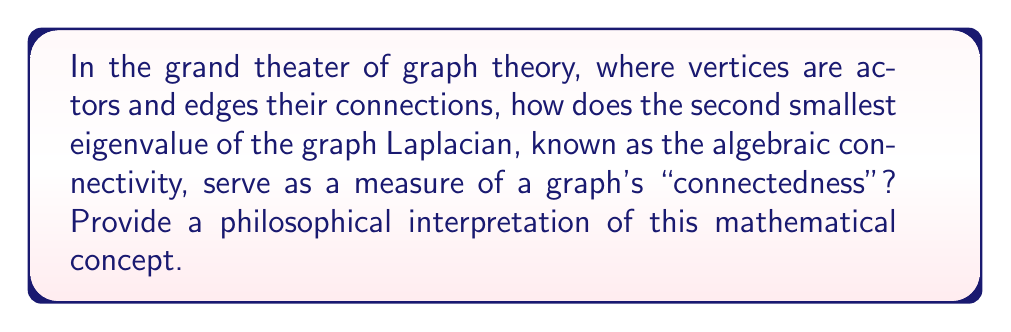What is the answer to this math problem? Let's approach this question step-by-step, intertwining mathematical rigor with philosophical musings:

1) First, we define the graph Laplacian matrix $L$ for an undirected graph $G$ with $n$ vertices:

   $$ L = D - A $$

   where $D$ is the degree matrix and $A$ is the adjacency matrix.

2) The eigenvalues of $L$ are real and non-negative, as $L$ is symmetric and positive semi-definite. Let's denote them as:

   $$ 0 = \lambda_1 \leq \lambda_2 \leq ... \leq \lambda_n $$

3) The second smallest eigenvalue, $\lambda_2$, is called the algebraic connectivity of the graph. It's always non-negative, and equals zero if and only if the graph is disconnected.

4) Now, let's ponder the philosophical implications. The algebraic connectivity $\lambda_2$ quantifies how well-connected the graph is as a whole. A larger $\lambda_2$ indicates a more robustly connected graph.

5) This can be interpreted as a measure of the graph's resilience to being divided. In a social network context, it could represent the cohesion of a community or the difficulty of polarizing a group.

6) The eigenvector corresponding to $\lambda_2$, known as the Fiedler vector, can be used to partition the graph. This raises intriguing questions about the nature of division and unity in complex systems.

7) Mathematically, $\lambda_2$ is related to the isoperimetric number of the graph, which measures the existence of bottlenecks. Philosophically, this connects to the idea of weak points in systems or arguments.

8) The reciprocal of $\lambda_2$ provides an upper bound on the graph's diameter. This relates the abstract notion of algebraic connectivity to the more intuitive concept of how "far apart" nodes in the graph can be.

9) In the context of random walks on graphs, $\lambda_2$ is related to the mixing time - how quickly the walk converges to its stationary distribution. This could be seen as a measure of how quickly information (or influence) spreads through a network.

Thus, the algebraic connectivity serves as a bridge between the abstract realm of linear algebra and the tangible properties of graphs, offering a rich ground for both mathematical analysis and philosophical contemplation.
Answer: $\lambda_2$ quantifies overall graph connectivity, reflecting system cohesion and resistance to division. 